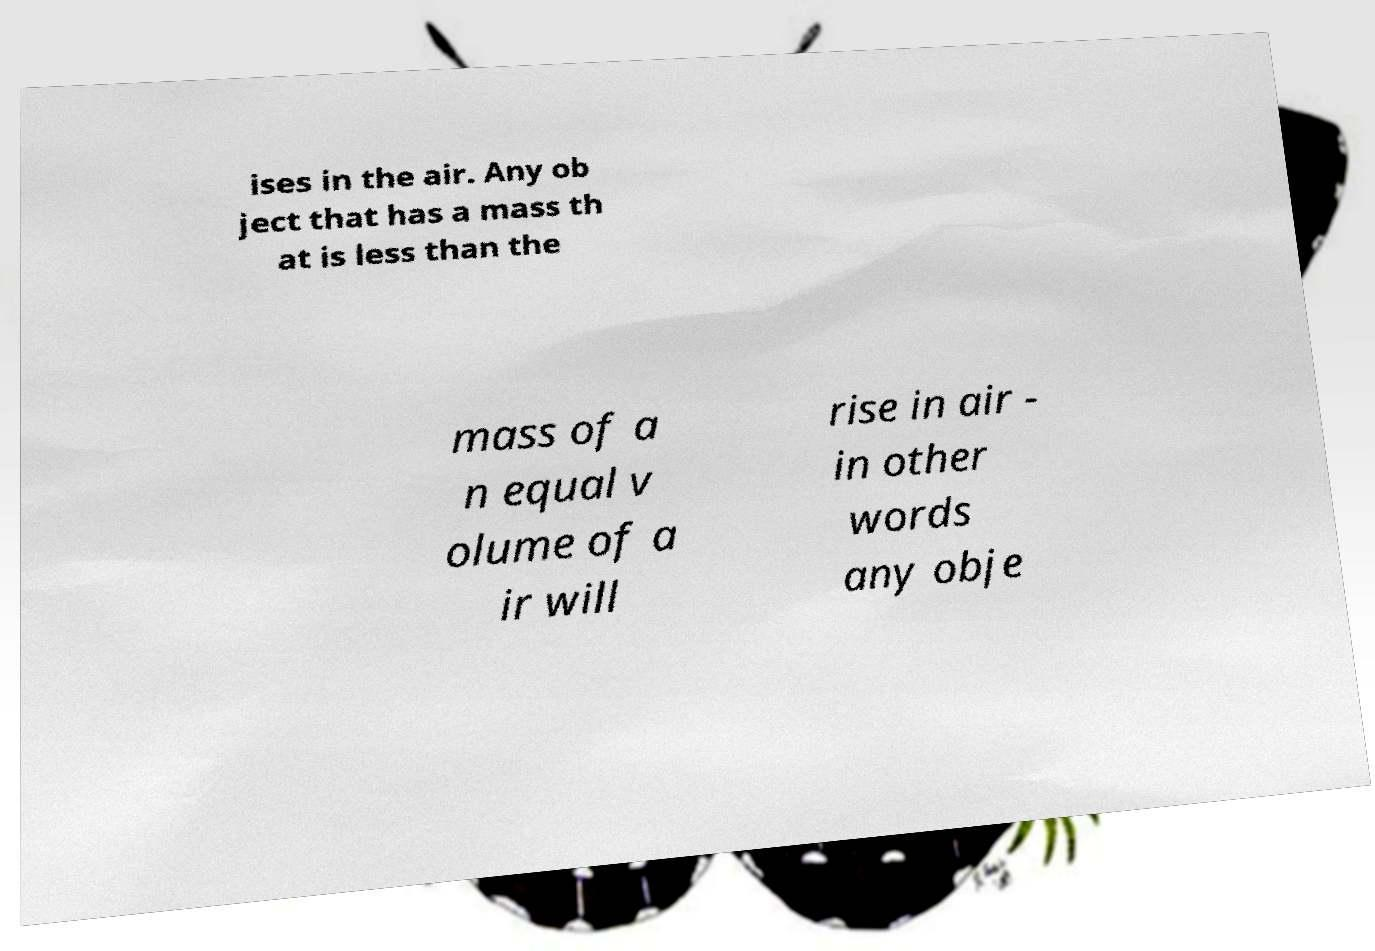Please identify and transcribe the text found in this image. ises in the air. Any ob ject that has a mass th at is less than the mass of a n equal v olume of a ir will rise in air - in other words any obje 